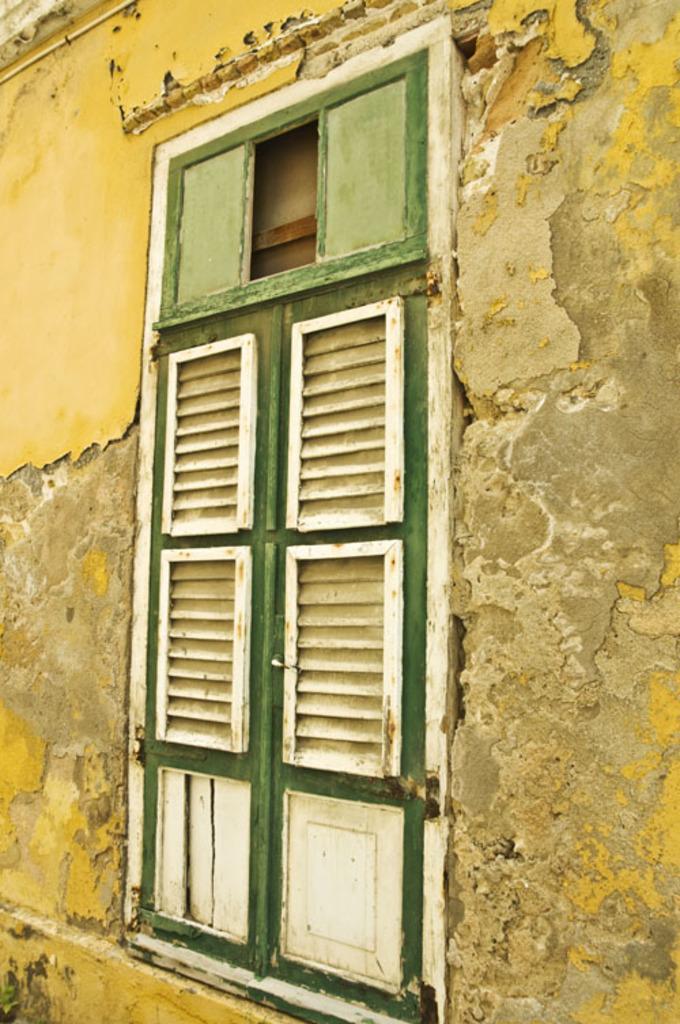In one or two sentences, can you explain what this image depicts? In the image there is a wall with windows. And the window is in green and white color. 